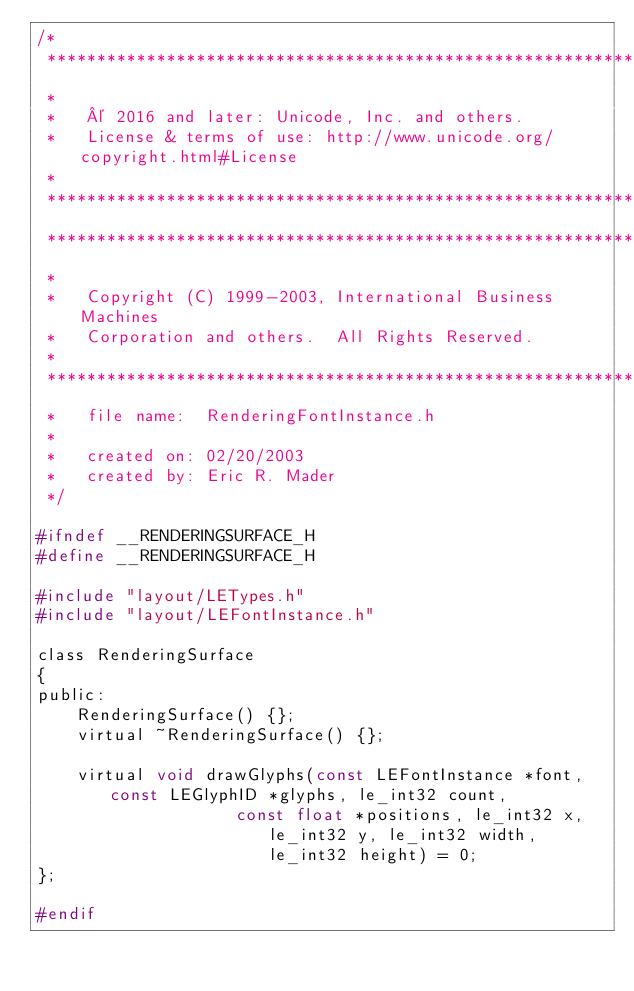Convert code to text. <code><loc_0><loc_0><loc_500><loc_500><_C_>/*
 *******************************************************************************
 *
 *   © 2016 and later: Unicode, Inc. and others.
 *   License & terms of use: http://www.unicode.org/copyright.html#License
 *
 *******************************************************************************
 *******************************************************************************
 *
 *   Copyright (C) 1999-2003, International Business Machines
 *   Corporation and others.  All Rights Reserved.
 *
 *******************************************************************************
 *   file name:  RenderingFontInstance.h
 *
 *   created on: 02/20/2003
 *   created by: Eric R. Mader
 */

#ifndef __RENDERINGSURFACE_H
#define __RENDERINGSURFACE_H

#include "layout/LETypes.h"
#include "layout/LEFontInstance.h"

class RenderingSurface
{
public:
    RenderingSurface() {};
    virtual ~RenderingSurface() {};

    virtual void drawGlyphs(const LEFontInstance *font, const LEGlyphID *glyphs, le_int32 count,
                    const float *positions, le_int32 x, le_int32 y, le_int32 width, le_int32 height) = 0;
};

#endif
</code> 